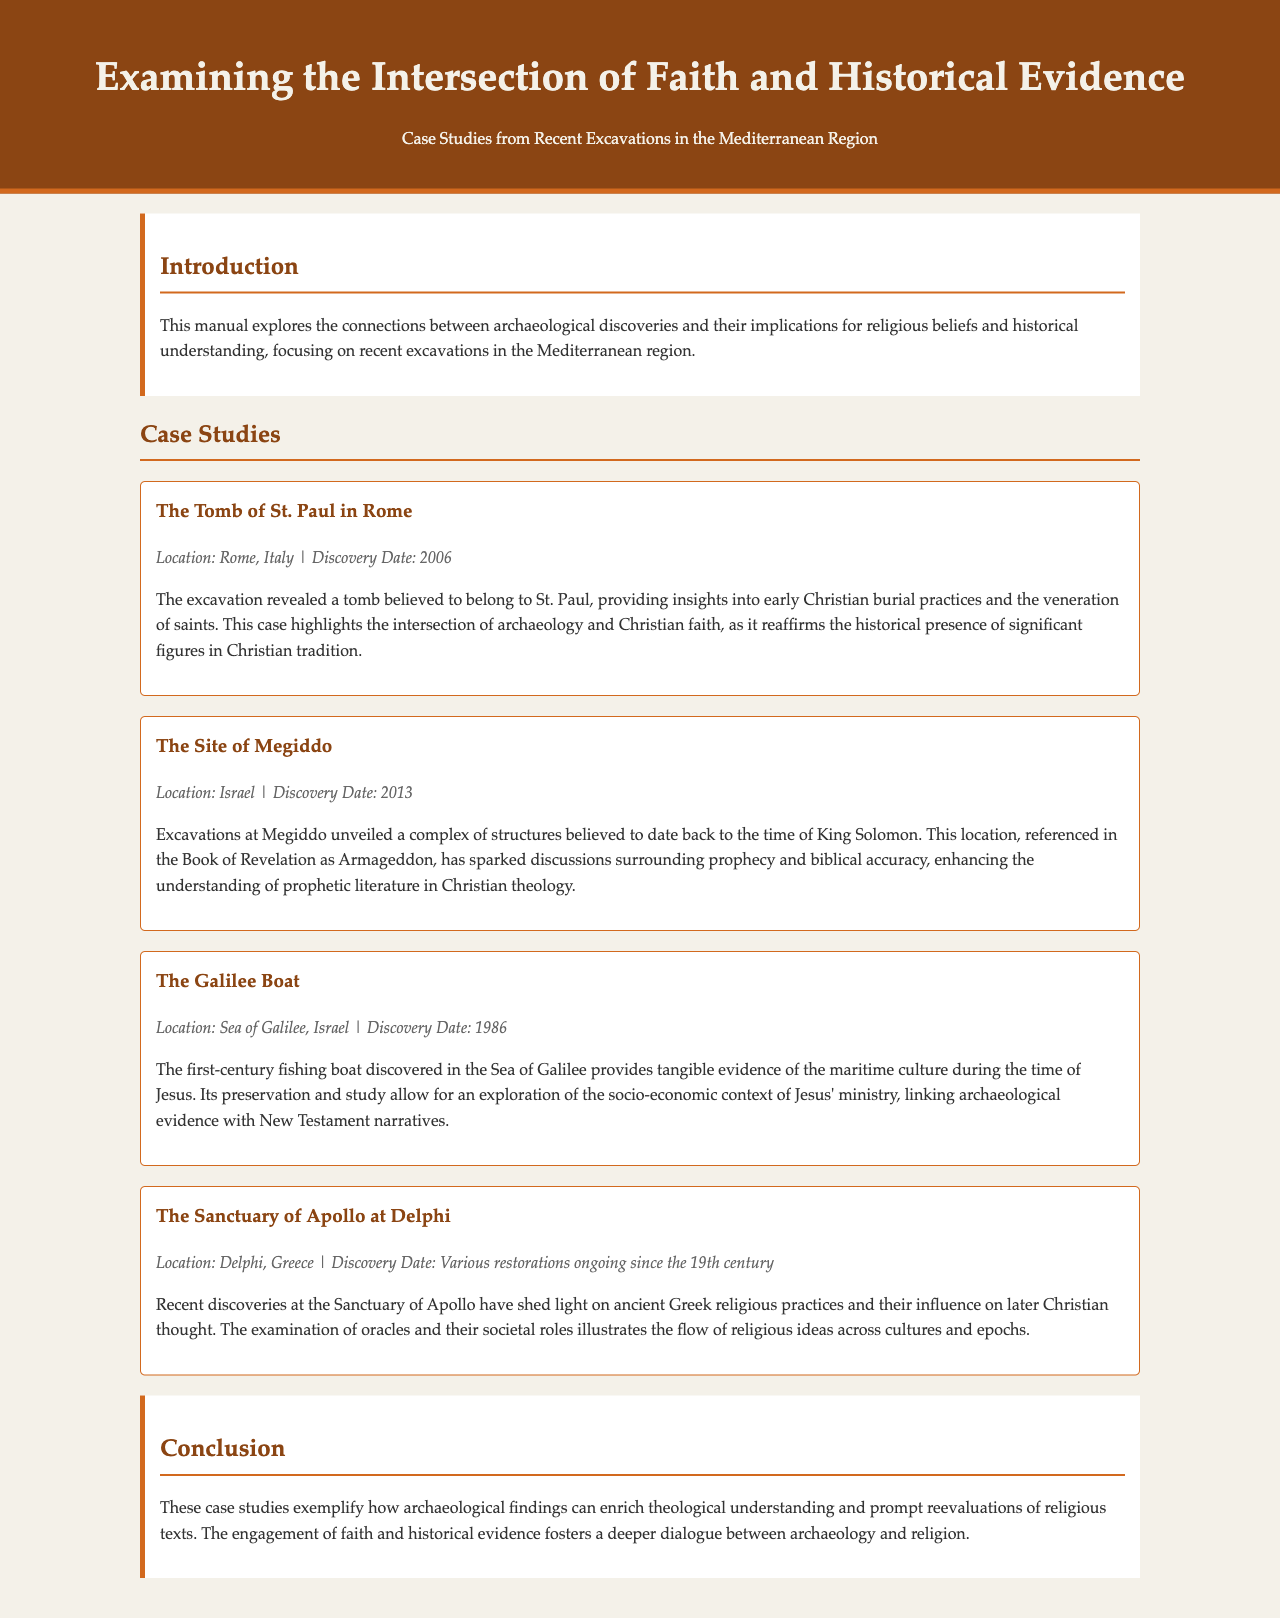What is the primary focus of the manual? The manual explores the connections between archaeological discoveries and their implications for religious beliefs and historical understanding.
Answer: Connections between archaeology and faith When was the Tomb of St. Paul discovered? The document states that the Tomb of St. Paul was discovered in 2006.
Answer: 2006 Which biblical location is identified in the case study of Megiddo? The document mentions that Megiddo is referenced in the Book of Revelation as Armageddon.
Answer: Armageddon What type of boat was discovered in the Sea of Galilee? The case study refers to a fishing boat discovered in the Sea of Galilee.
Answer: Fishing boat What is significant about the Sanctuary of Apollo at Delphi? Recent discoveries have shed light on ancient Greek religious practices and their influence on later Christian thought.
Answer: Influence on Christian thought How many case studies are mentioned in the document? The document discusses four case studies.
Answer: Four What overarching theme is presented in the conclusion of the manual? The conclusion emphasizes how archaeological findings can enrich theological understanding.
Answer: Enrichment of theological understanding What material does the document suggest regarding the socio-economic context of Jesus' ministry? The Galilee Boat provides evidence of the maritime culture during the time of Jesus.
Answer: Maritime culture What genre does this document belong to? The document is a manual that examines the intersection of faith and historical evidence.
Answer: Manual 